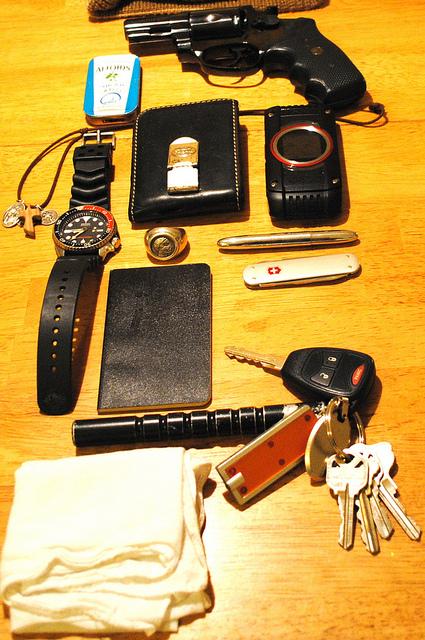Where are the keys?
Keep it brief. Table. What item is at the top of the table?
Keep it brief. Gun. How many sets of keys are visible?
Be succinct. 1. How many items?
Keep it brief. 13. 